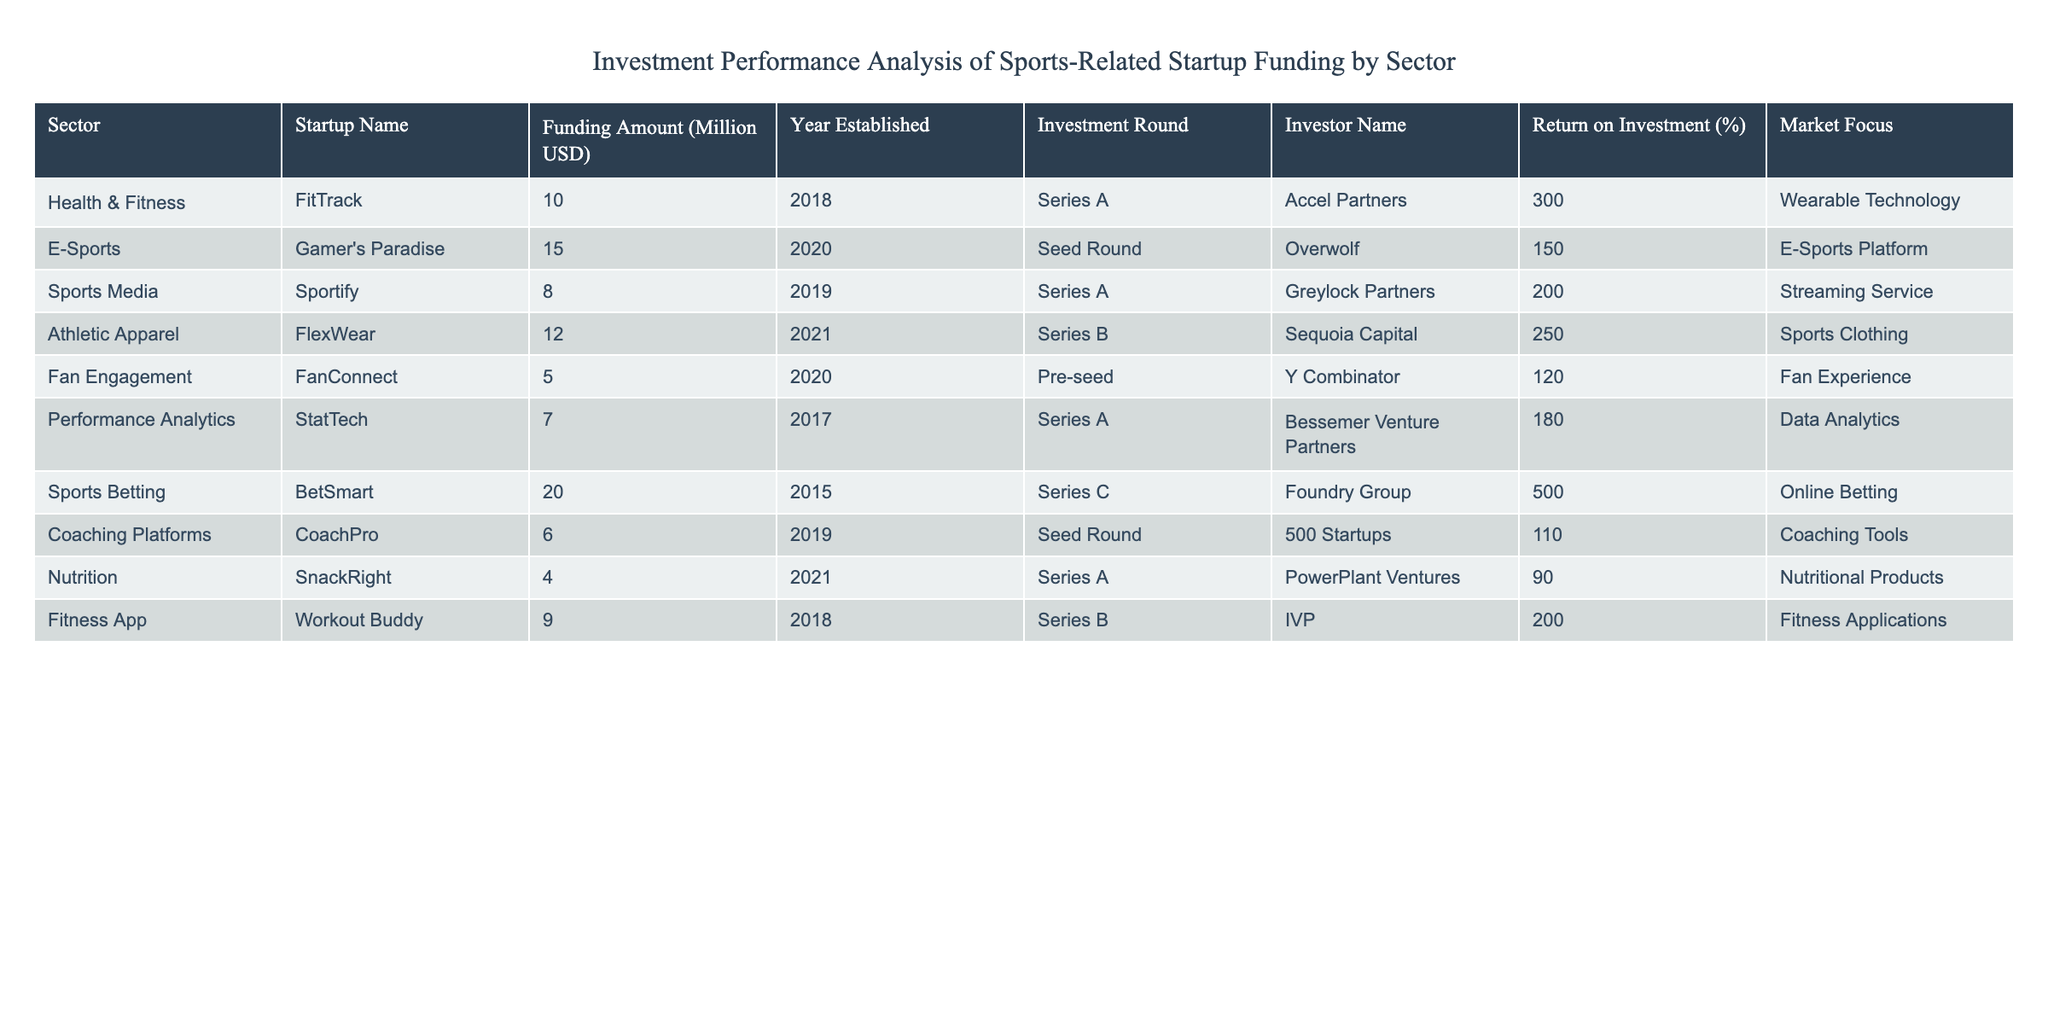What is the total funding amount across all startups listed? To find the total funding amount, sum the "Funding Amount (Million USD)" for each startup. The values are 10, 15, 8, 12, 5, 7, 20, 6, 4, and 9. Therefore, the total is 10 + 15 + 8 + 12 + 5 + 7 + 20 + 6 + 4 + 9 = 96 million USD.
Answer: 96 million USD Which startup has the highest return on investment? The return on investment (ROI) percentages are listed as 300, 150, 200, 250, 120, 180, 500, 110, 90, and 200. The highest ROI is 500%, which corresponds to BetSmart.
Answer: BetSmart Are there any startups established in the year 2021? By examining the "Year Established" column, startups like FlexWear and SnackRight show the year as 2021. Thus, there are startups established in 2021.
Answer: Yes What is the average return on investment for health and fitness startups? Two startups fall under the Health & Fitness sector: FitTrack with an ROI of 300% and SnackRight with an ROI of 90%. The average ROI is calculated as (300 + 90) / 2 = 195%.
Answer: 195% Which sectors have startups with a return on investment greater than 200%? Review the table for ROIs above 200%, which are for FitTrack (300%) and BetSmart (500%). FitTrack is in Health & Fitness, and BetSmart is in Sports Betting. Both belong to different sectors.
Answer: Health & Fitness, Sports Betting What is the total amount of funding received by e-sports startups? The e-sports startup listed is Gamer’s Paradise, which received funding of 15 million USD. Since no other e-sports startups are indicated, this amount is total for the sector.
Answer: 15 million USD Is there a coaching platform startup listed in the table? The table contains a startup named CoachPro listed under "Coaching Platforms." Therefore, yes, there is a coaching platform startup.
Answer: Yes What is the difference between the highest and lowest funding amounts in the table? The highest funding amount is 20 million USD from BetSmart, and the lowest is 4 million USD from SnackRight. The difference is 20 - 4 = 16 million USD.
Answer: 16 million USD How many startups have been established before 2020? By reviewing the "Year Established," the startups established before 2020 are FitTrack (2018), StatTech (2017), and BetSmart (2015). Altogether, that makes three startups.
Answer: 3 